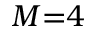Convert formula to latex. <formula><loc_0><loc_0><loc_500><loc_500>M { = } 4</formula> 